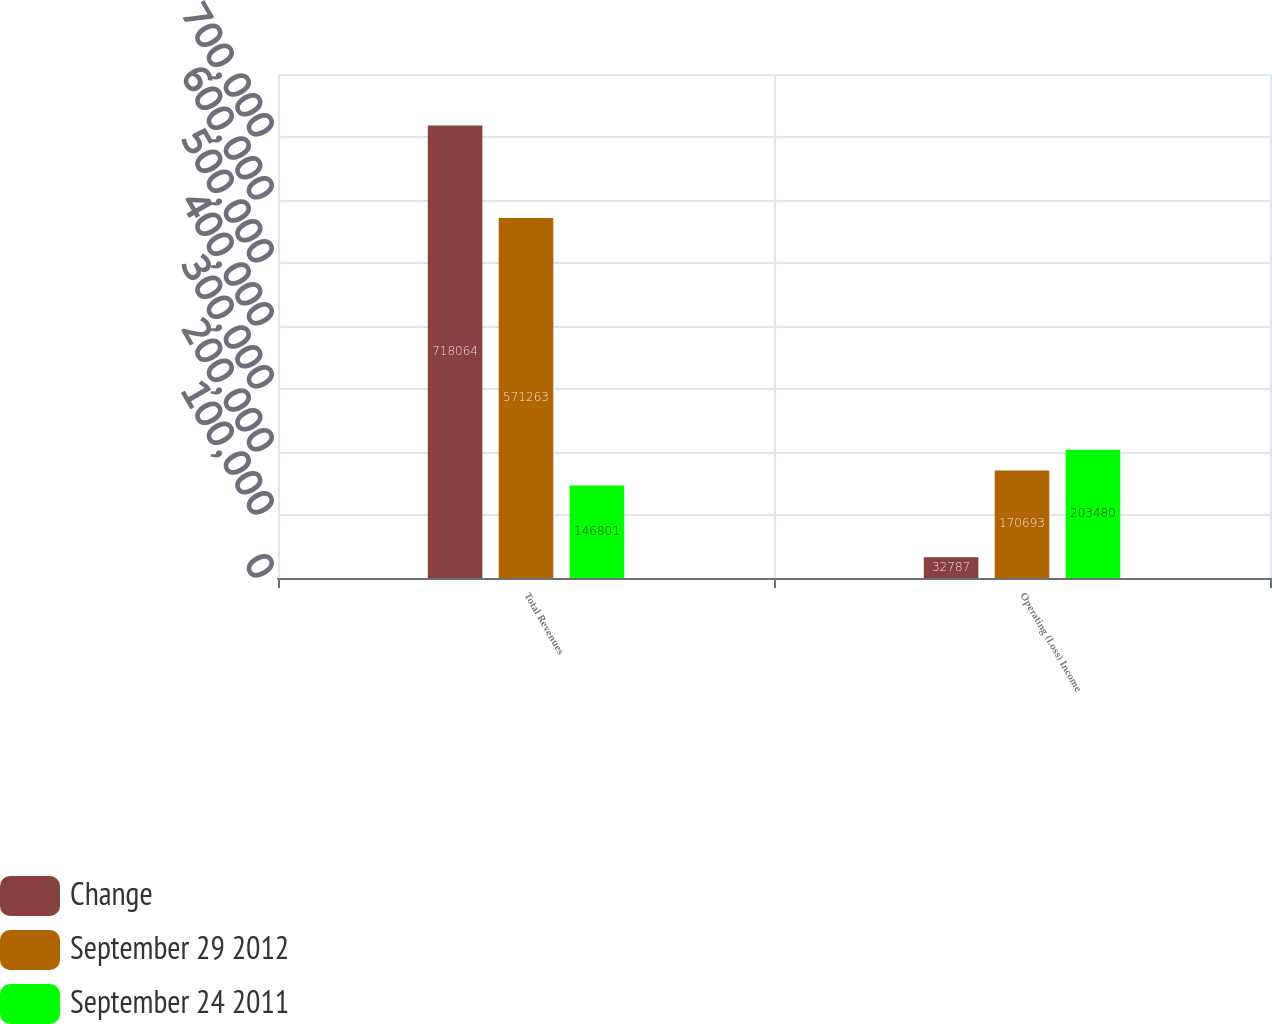Convert chart to OTSL. <chart><loc_0><loc_0><loc_500><loc_500><stacked_bar_chart><ecel><fcel>Total Revenues<fcel>Operating (Loss) Income<nl><fcel>Change<fcel>718064<fcel>32787<nl><fcel>September 29 2012<fcel>571263<fcel>170693<nl><fcel>September 24 2011<fcel>146801<fcel>203480<nl></chart> 